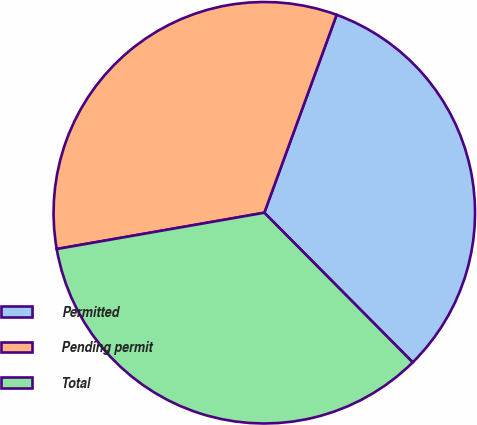Convert chart. <chart><loc_0><loc_0><loc_500><loc_500><pie_chart><fcel>Permitted<fcel>Pending permit<fcel>Total<nl><fcel>31.99%<fcel>33.33%<fcel>34.68%<nl></chart> 